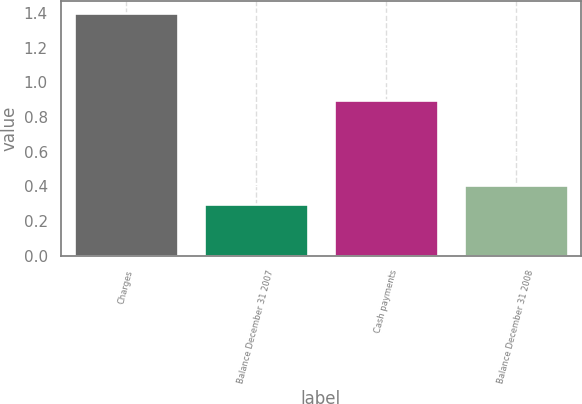<chart> <loc_0><loc_0><loc_500><loc_500><bar_chart><fcel>Charges<fcel>Balance December 31 2007<fcel>Cash payments<fcel>Balance December 31 2008<nl><fcel>1.4<fcel>0.3<fcel>0.9<fcel>0.41<nl></chart> 